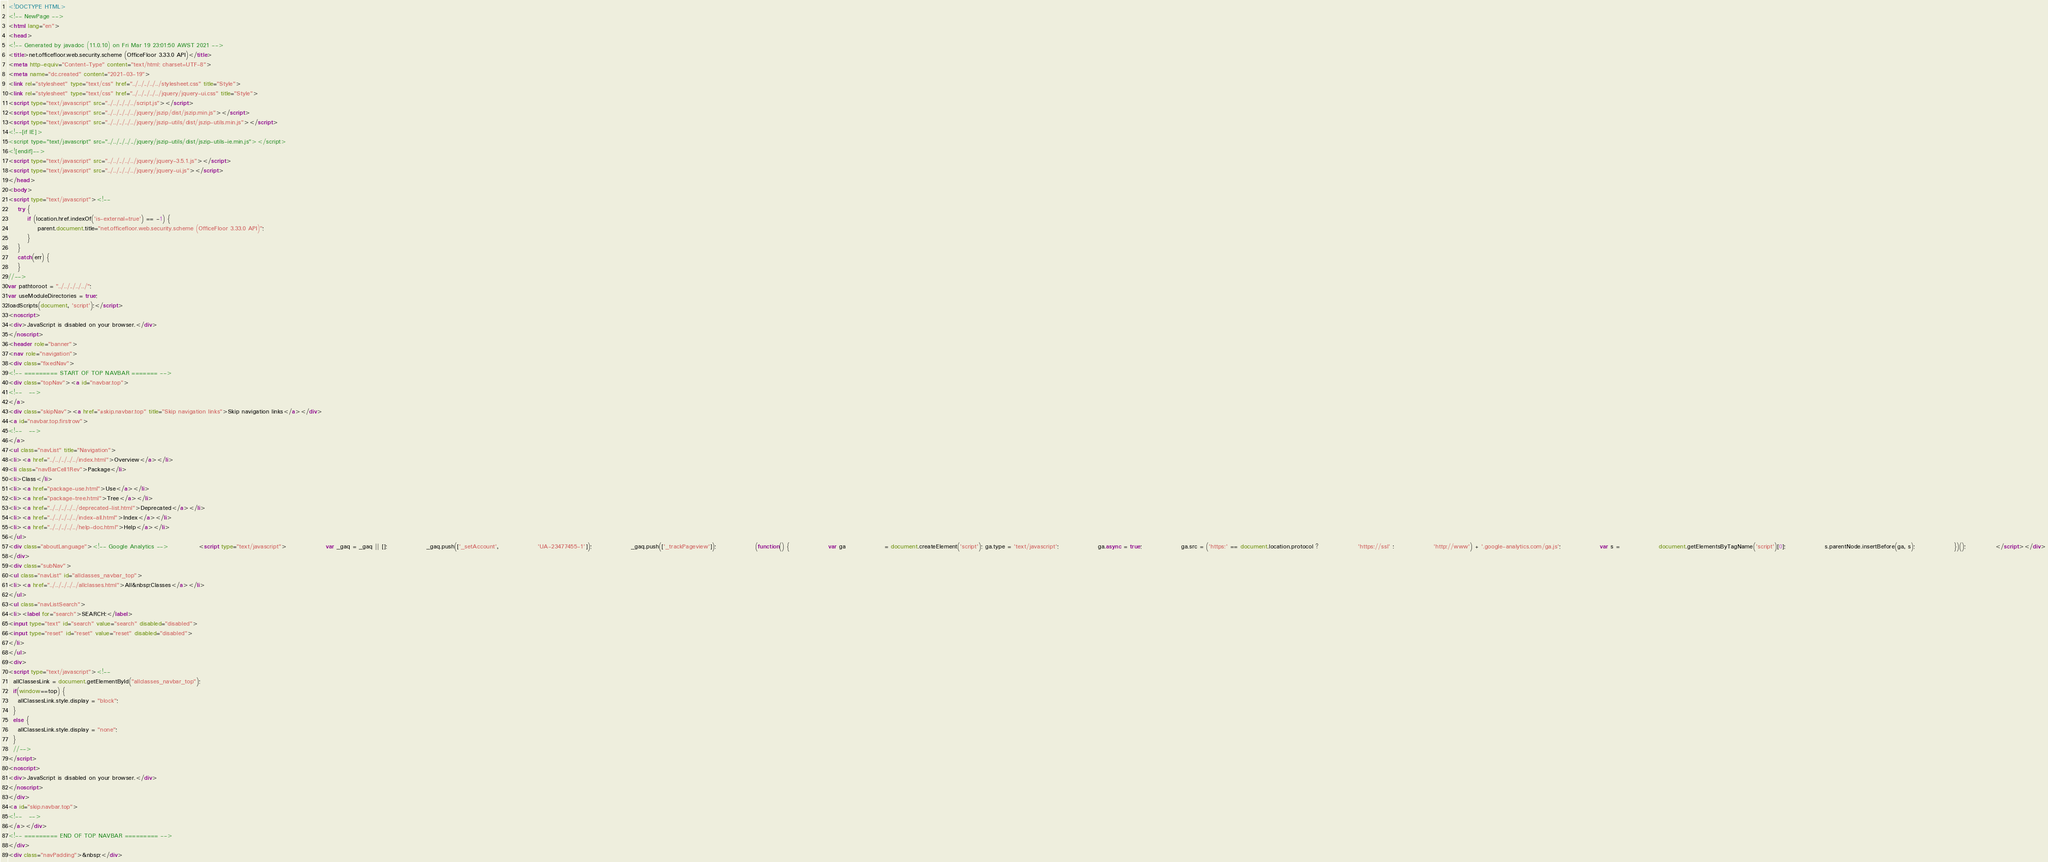Convert code to text. <code><loc_0><loc_0><loc_500><loc_500><_HTML_><!DOCTYPE HTML>
<!-- NewPage -->
<html lang="en">
<head>
<!-- Generated by javadoc (11.0.10) on Fri Mar 19 23:01:50 AWST 2021 -->
<title>net.officefloor.web.security.scheme (OfficeFloor 3.33.0 API)</title>
<meta http-equiv="Content-Type" content="text/html; charset=UTF-8">
<meta name="dc.created" content="2021-03-19">
<link rel="stylesheet" type="text/css" href="../../../../../stylesheet.css" title="Style">
<link rel="stylesheet" type="text/css" href="../../../../../jquery/jquery-ui.css" title="Style">
<script type="text/javascript" src="../../../../../script.js"></script>
<script type="text/javascript" src="../../../../../jquery/jszip/dist/jszip.min.js"></script>
<script type="text/javascript" src="../../../../../jquery/jszip-utils/dist/jszip-utils.min.js"></script>
<!--[if IE]>
<script type="text/javascript" src="../../../../../jquery/jszip-utils/dist/jszip-utils-ie.min.js"></script>
<![endif]-->
<script type="text/javascript" src="../../../../../jquery/jquery-3.5.1.js"></script>
<script type="text/javascript" src="../../../../../jquery/jquery-ui.js"></script>
</head>
<body>
<script type="text/javascript"><!--
    try {
        if (location.href.indexOf('is-external=true') == -1) {
            parent.document.title="net.officefloor.web.security.scheme (OfficeFloor 3.33.0 API)";
        }
    }
    catch(err) {
    }
//-->
var pathtoroot = "../../../../../";
var useModuleDirectories = true;
loadScripts(document, 'script');</script>
<noscript>
<div>JavaScript is disabled on your browser.</div>
</noscript>
<header role="banner">
<nav role="navigation">
<div class="fixedNav">
<!-- ========= START OF TOP NAVBAR ======= -->
<div class="topNav"><a id="navbar.top">
<!--   -->
</a>
<div class="skipNav"><a href="#skip.navbar.top" title="Skip navigation links">Skip navigation links</a></div>
<a id="navbar.top.firstrow">
<!--   -->
</a>
<ul class="navList" title="Navigation">
<li><a href="../../../../../index.html">Overview</a></li>
<li class="navBarCell1Rev">Package</li>
<li>Class</li>
<li><a href="package-use.html">Use</a></li>
<li><a href="package-tree.html">Tree</a></li>
<li><a href="../../../../../deprecated-list.html">Deprecated</a></li>
<li><a href="../../../../../index-all.html">Index</a></li>
<li><a href="../../../../../help-doc.html">Help</a></li>
</ul>
<div class="aboutLanguage"><!-- Google Analytics --> 			<script type="text/javascript"> 				var _gaq = _gaq || []; 				_gaq.push(['_setAccount', 				'UA-23477455-1']); 				_gaq.push(['_trackPageview']);  				(function() { 				var ga 				= document.createElement('script'); ga.type = 'text/javascript'; 				ga.async = true; 				ga.src = ('https:' == document.location.protocol ? 				'https://ssl' : 				'http://www') + '.google-analytics.com/ga.js'; 				var s = 				document.getElementsByTagName('script')[0]; 				s.parentNode.insertBefore(ga, s); 				})(); 			</script></div>
</div>
<div class="subNav">
<ul class="navList" id="allclasses_navbar_top">
<li><a href="../../../../../allclasses.html">All&nbsp;Classes</a></li>
</ul>
<ul class="navListSearch">
<li><label for="search">SEARCH:</label>
<input type="text" id="search" value="search" disabled="disabled">
<input type="reset" id="reset" value="reset" disabled="disabled">
</li>
</ul>
<div>
<script type="text/javascript"><!--
  allClassesLink = document.getElementById("allclasses_navbar_top");
  if(window==top) {
    allClassesLink.style.display = "block";
  }
  else {
    allClassesLink.style.display = "none";
  }
  //-->
</script>
<noscript>
<div>JavaScript is disabled on your browser.</div>
</noscript>
</div>
<a id="skip.navbar.top">
<!--   -->
</a></div>
<!-- ========= END OF TOP NAVBAR ========= -->
</div>
<div class="navPadding">&nbsp;</div></code> 